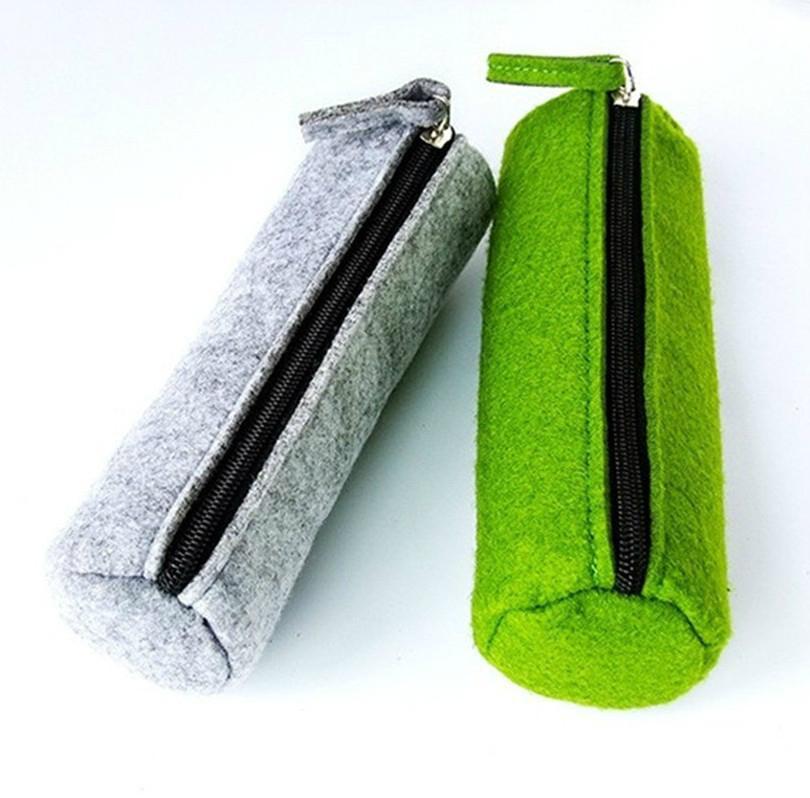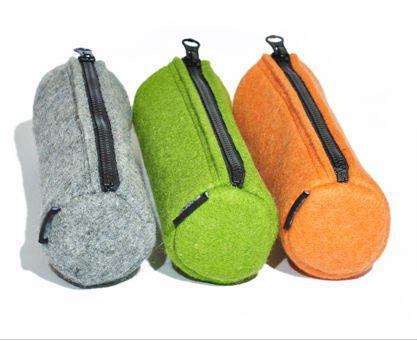The first image is the image on the left, the second image is the image on the right. For the images shown, is this caption "The left image contains a gray tube-shaped zipper case to the left of a green one, and the right image includes gray, green and orange closed tube-shaped cases." true? Answer yes or no. Yes. The first image is the image on the left, the second image is the image on the right. Examine the images to the left and right. Is the description "There are five or more felt pencil cases." accurate? Answer yes or no. Yes. 